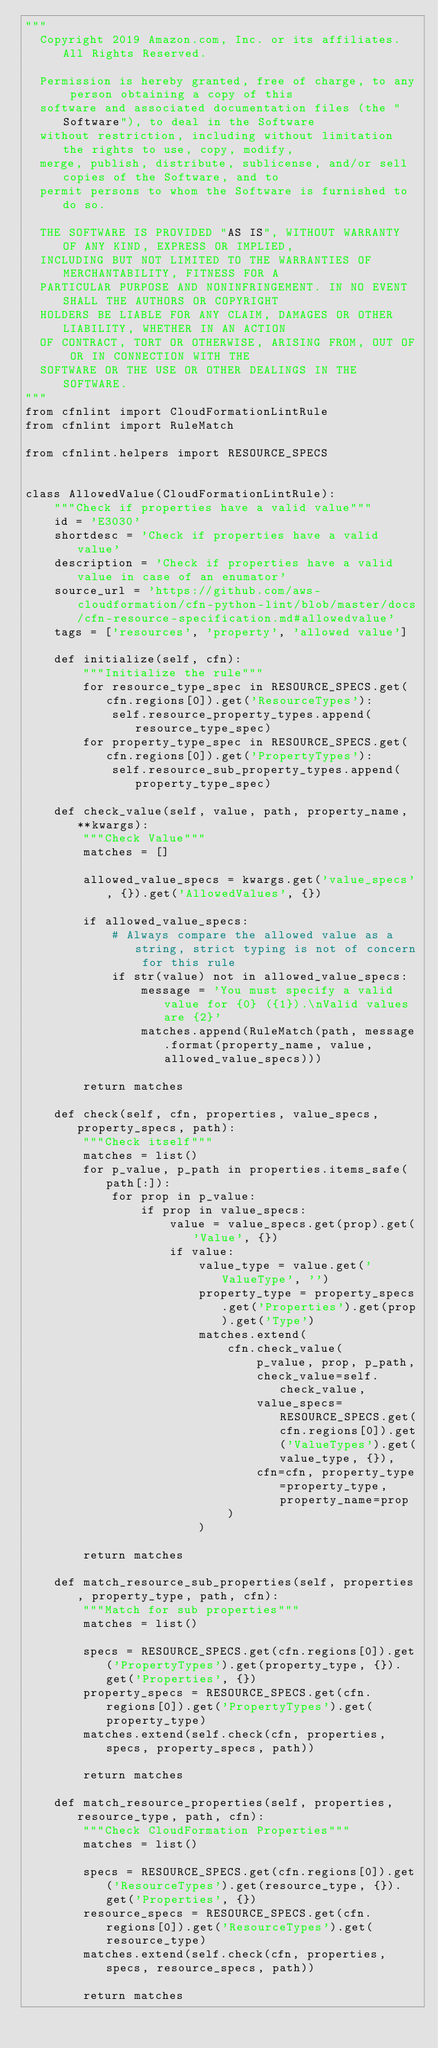Convert code to text. <code><loc_0><loc_0><loc_500><loc_500><_Python_>"""
  Copyright 2019 Amazon.com, Inc. or its affiliates. All Rights Reserved.

  Permission is hereby granted, free of charge, to any person obtaining a copy of this
  software and associated documentation files (the "Software"), to deal in the Software
  without restriction, including without limitation the rights to use, copy, modify,
  merge, publish, distribute, sublicense, and/or sell copies of the Software, and to
  permit persons to whom the Software is furnished to do so.

  THE SOFTWARE IS PROVIDED "AS IS", WITHOUT WARRANTY OF ANY KIND, EXPRESS OR IMPLIED,
  INCLUDING BUT NOT LIMITED TO THE WARRANTIES OF MERCHANTABILITY, FITNESS FOR A
  PARTICULAR PURPOSE AND NONINFRINGEMENT. IN NO EVENT SHALL THE AUTHORS OR COPYRIGHT
  HOLDERS BE LIABLE FOR ANY CLAIM, DAMAGES OR OTHER LIABILITY, WHETHER IN AN ACTION
  OF CONTRACT, TORT OR OTHERWISE, ARISING FROM, OUT OF OR IN CONNECTION WITH THE
  SOFTWARE OR THE USE OR OTHER DEALINGS IN THE SOFTWARE.
"""
from cfnlint import CloudFormationLintRule
from cfnlint import RuleMatch

from cfnlint.helpers import RESOURCE_SPECS


class AllowedValue(CloudFormationLintRule):
    """Check if properties have a valid value"""
    id = 'E3030'
    shortdesc = 'Check if properties have a valid value'
    description = 'Check if properties have a valid value in case of an enumator'
    source_url = 'https://github.com/aws-cloudformation/cfn-python-lint/blob/master/docs/cfn-resource-specification.md#allowedvalue'
    tags = ['resources', 'property', 'allowed value']

    def initialize(self, cfn):
        """Initialize the rule"""
        for resource_type_spec in RESOURCE_SPECS.get(cfn.regions[0]).get('ResourceTypes'):
            self.resource_property_types.append(resource_type_spec)
        for property_type_spec in RESOURCE_SPECS.get(cfn.regions[0]).get('PropertyTypes'):
            self.resource_sub_property_types.append(property_type_spec)

    def check_value(self, value, path, property_name, **kwargs):
        """Check Value"""
        matches = []

        allowed_value_specs = kwargs.get('value_specs', {}).get('AllowedValues', {})

        if allowed_value_specs:
            # Always compare the allowed value as a string, strict typing is not of concern for this rule
            if str(value) not in allowed_value_specs:
                message = 'You must specify a valid value for {0} ({1}).\nValid values are {2}'
                matches.append(RuleMatch(path, message.format(property_name, value, allowed_value_specs)))

        return matches

    def check(self, cfn, properties, value_specs, property_specs, path):
        """Check itself"""
        matches = list()
        for p_value, p_path in properties.items_safe(path[:]):
            for prop in p_value:
                if prop in value_specs:
                    value = value_specs.get(prop).get('Value', {})
                    if value:
                        value_type = value.get('ValueType', '')
                        property_type = property_specs.get('Properties').get(prop).get('Type')
                        matches.extend(
                            cfn.check_value(
                                p_value, prop, p_path,
                                check_value=self.check_value,
                                value_specs=RESOURCE_SPECS.get(cfn.regions[0]).get('ValueTypes').get(value_type, {}),
                                cfn=cfn, property_type=property_type, property_name=prop
                            )
                        )

        return matches

    def match_resource_sub_properties(self, properties, property_type, path, cfn):
        """Match for sub properties"""
        matches = list()

        specs = RESOURCE_SPECS.get(cfn.regions[0]).get('PropertyTypes').get(property_type, {}).get('Properties', {})
        property_specs = RESOURCE_SPECS.get(cfn.regions[0]).get('PropertyTypes').get(property_type)
        matches.extend(self.check(cfn, properties, specs, property_specs, path))

        return matches

    def match_resource_properties(self, properties, resource_type, path, cfn):
        """Check CloudFormation Properties"""
        matches = list()

        specs = RESOURCE_SPECS.get(cfn.regions[0]).get('ResourceTypes').get(resource_type, {}).get('Properties', {})
        resource_specs = RESOURCE_SPECS.get(cfn.regions[0]).get('ResourceTypes').get(resource_type)
        matches.extend(self.check(cfn, properties, specs, resource_specs, path))

        return matches
</code> 